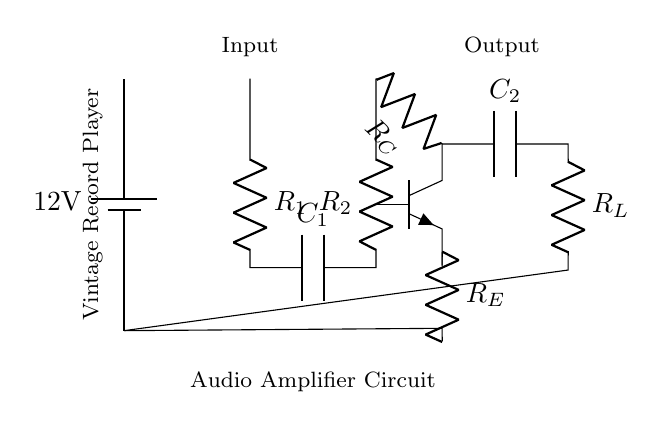What is the input voltage of this circuit? The diagram indicates that the circuit uses a battery as the power supply, and the voltage specified next to the battery symbol is twelve volts.
Answer: twelve volts What component is primarily responsible for amplification? In the diagram, the transistor is the main component responsible for amplification, as it is positioned in the middle of the circuit and is labeled as an npn transistor.
Answer: transistor What is the value of the capacitor connected at the output stage? The diagram shows a capacitor labeled C2, but does not specify its value, thus I can only confirm its presence as a crucial element in coupling to the output stage.
Answer: C2 Which component ensures stability by providing feedback in this amplifier? The resistor labeled R_E is connected to the emitter of the transistor, serving as an emitter resistor that helps stabilize the amplifier's gain.
Answer: R_E What is the purpose of the resistor R_1 in the input stage? Resistor R_1 is part of the input stage and plays a role in the signal conditioning process, acting as a load that allows the signal to develop across it before reaching the next component in the circuit.
Answer: R_1 Why is a capacitor connected at the output stage? The capacitor, labeled C2, is used at the output stage to block any DC voltage while allowing AC signals to pass, which is essential for audio applications to ensure only the desired audio frequencies are amplified to the output.
Answer: block DC voltage 